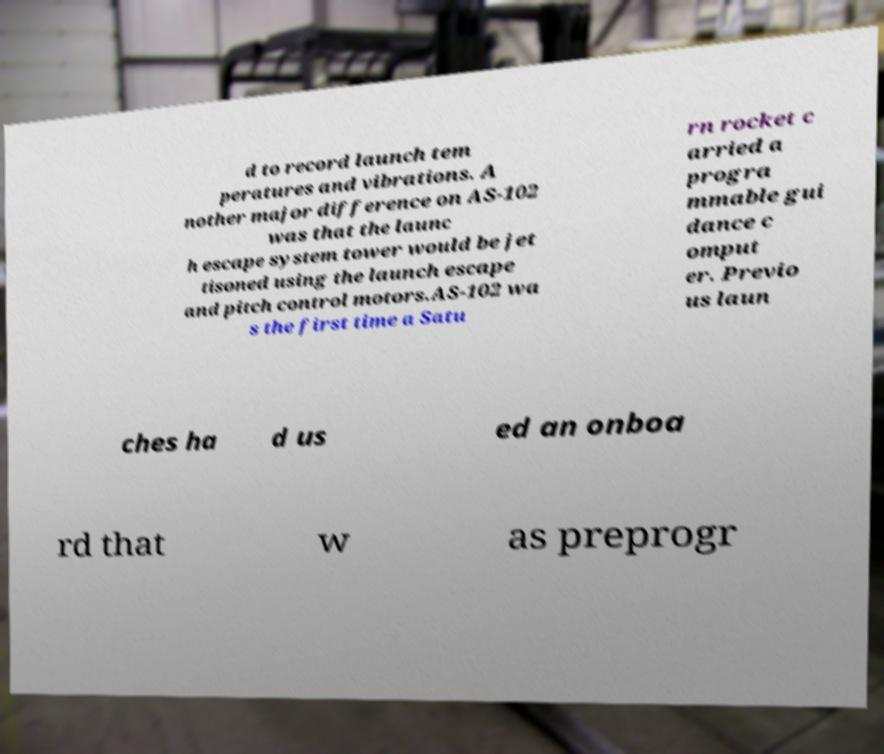Could you assist in decoding the text presented in this image and type it out clearly? d to record launch tem peratures and vibrations. A nother major difference on AS-102 was that the launc h escape system tower would be jet tisoned using the launch escape and pitch control motors.AS-102 wa s the first time a Satu rn rocket c arried a progra mmable gui dance c omput er. Previo us laun ches ha d us ed an onboa rd that w as preprogr 